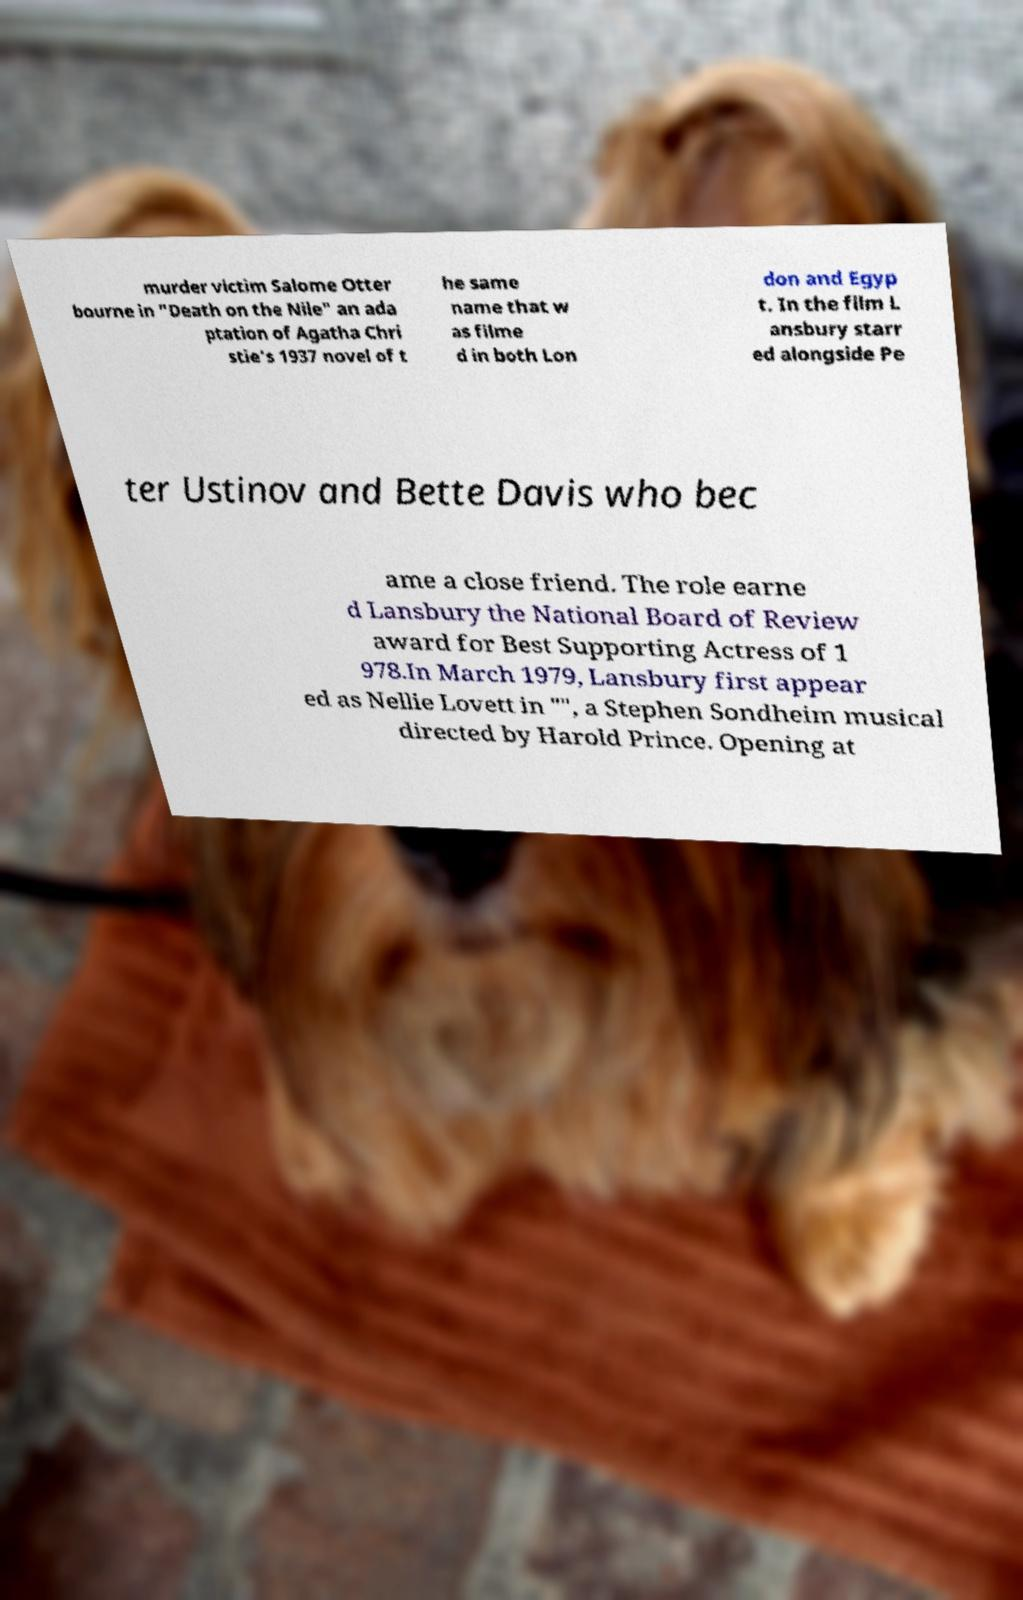I need the written content from this picture converted into text. Can you do that? murder victim Salome Otter bourne in "Death on the Nile" an ada ptation of Agatha Chri stie's 1937 novel of t he same name that w as filme d in both Lon don and Egyp t. In the film L ansbury starr ed alongside Pe ter Ustinov and Bette Davis who bec ame a close friend. The role earne d Lansbury the National Board of Review award for Best Supporting Actress of 1 978.In March 1979, Lansbury first appear ed as Nellie Lovett in "", a Stephen Sondheim musical directed by Harold Prince. Opening at 